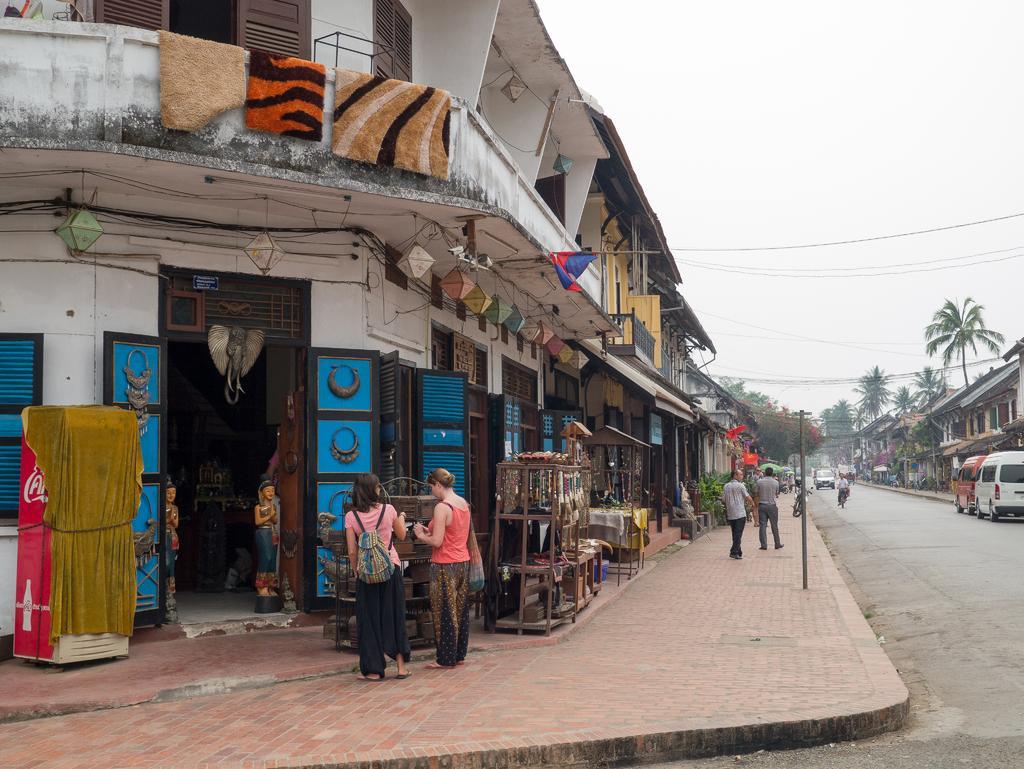In one or two sentences, can you explain what this image depicts? In this image there is the sky truncated towards the top of the image, there is a building truncated towards the left of the image, there are doors, there are windows, there are clothes, there are flags, there are objects on the ground, there are persons standing, there are persons walking, there are buildings truncated towards the right of the image, there are vehicles truncated towards the right of the image, there is the road towards the right of the image, there are vehicles on the road, there are persons wearing bags, there is a refrigerator, there are wires, there is a board, there is text on the board. 